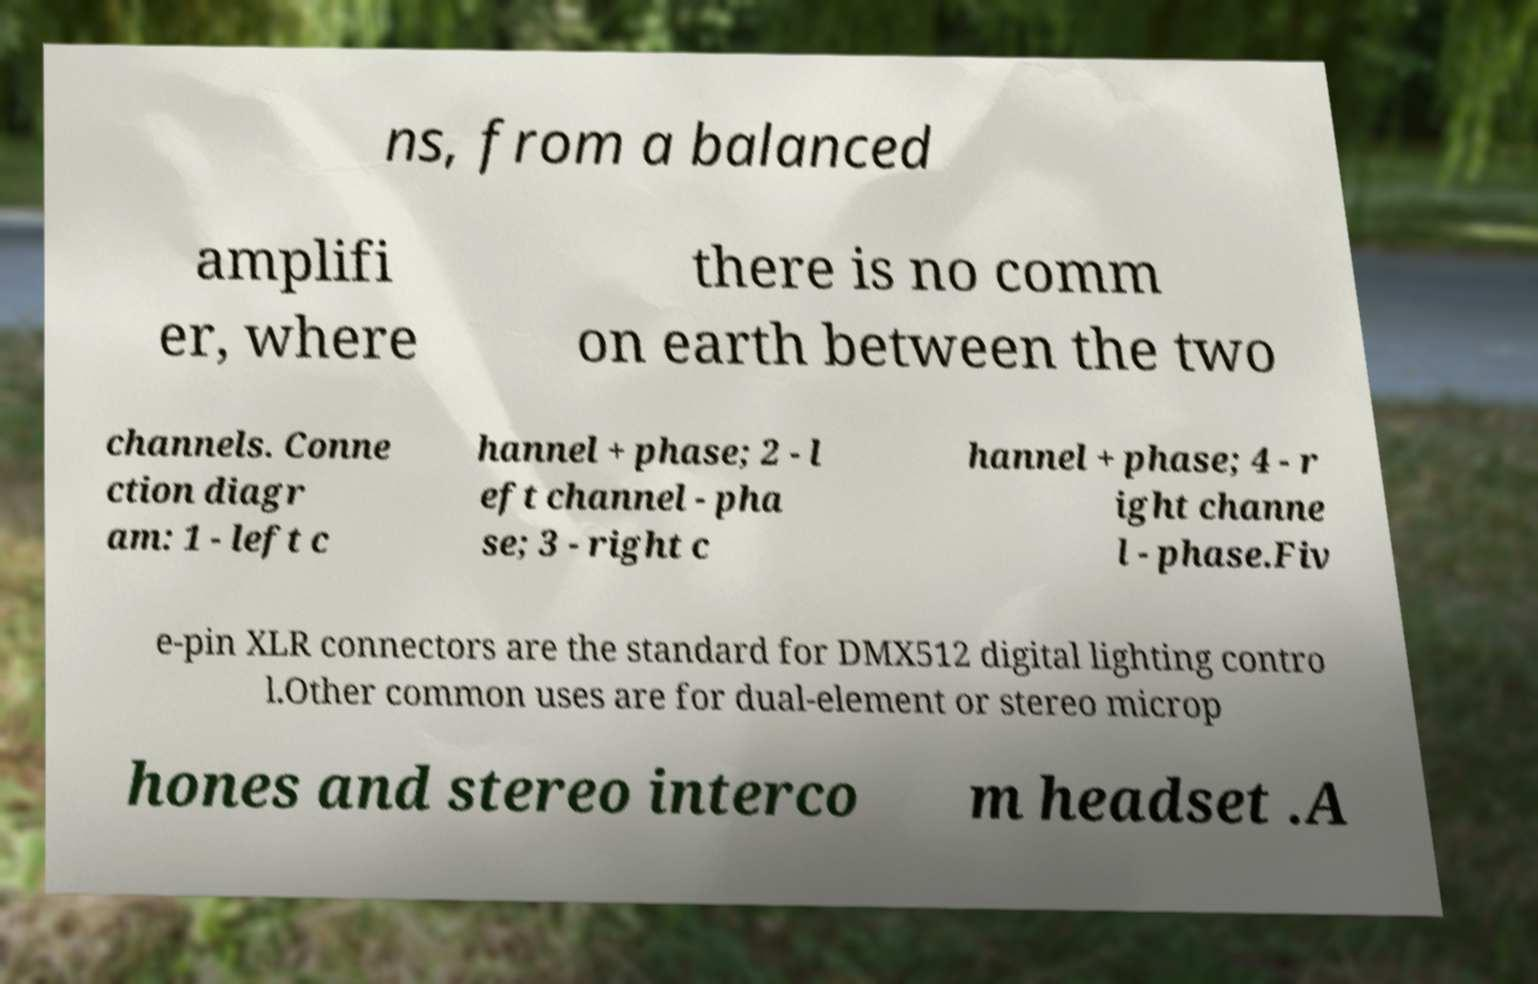Can you read and provide the text displayed in the image?This photo seems to have some interesting text. Can you extract and type it out for me? ns, from a balanced amplifi er, where there is no comm on earth between the two channels. Conne ction diagr am: 1 - left c hannel + phase; 2 - l eft channel - pha se; 3 - right c hannel + phase; 4 - r ight channe l - phase.Fiv e-pin XLR connectors are the standard for DMX512 digital lighting contro l.Other common uses are for dual-element or stereo microp hones and stereo interco m headset .A 